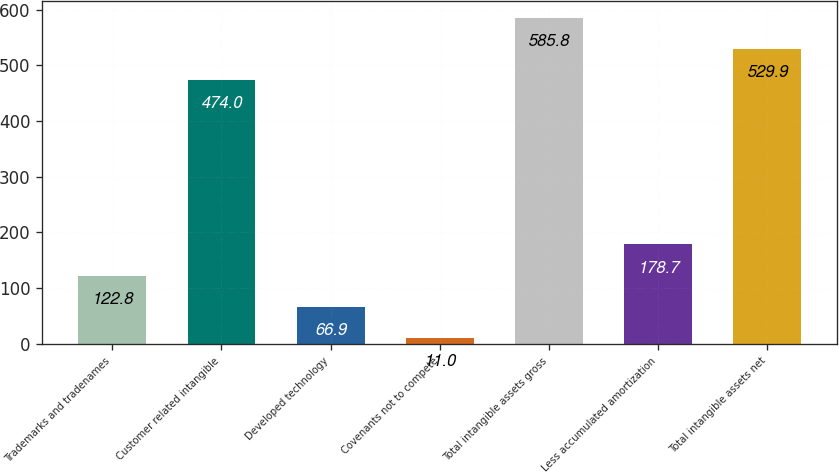Convert chart. <chart><loc_0><loc_0><loc_500><loc_500><bar_chart><fcel>Trademarks and tradenames<fcel>Customer related intangible<fcel>Developed technology<fcel>Covenants not to compete<fcel>Total intangible assets gross<fcel>Less accumulated amortization<fcel>Total intangible assets net<nl><fcel>122.8<fcel>474<fcel>66.9<fcel>11<fcel>585.8<fcel>178.7<fcel>529.9<nl></chart> 